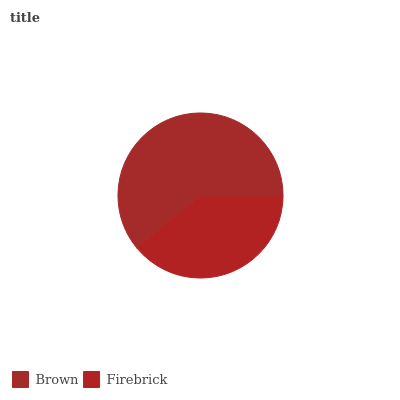Is Firebrick the minimum?
Answer yes or no. Yes. Is Brown the maximum?
Answer yes or no. Yes. Is Firebrick the maximum?
Answer yes or no. No. Is Brown greater than Firebrick?
Answer yes or no. Yes. Is Firebrick less than Brown?
Answer yes or no. Yes. Is Firebrick greater than Brown?
Answer yes or no. No. Is Brown less than Firebrick?
Answer yes or no. No. Is Brown the high median?
Answer yes or no. Yes. Is Firebrick the low median?
Answer yes or no. Yes. Is Firebrick the high median?
Answer yes or no. No. Is Brown the low median?
Answer yes or no. No. 